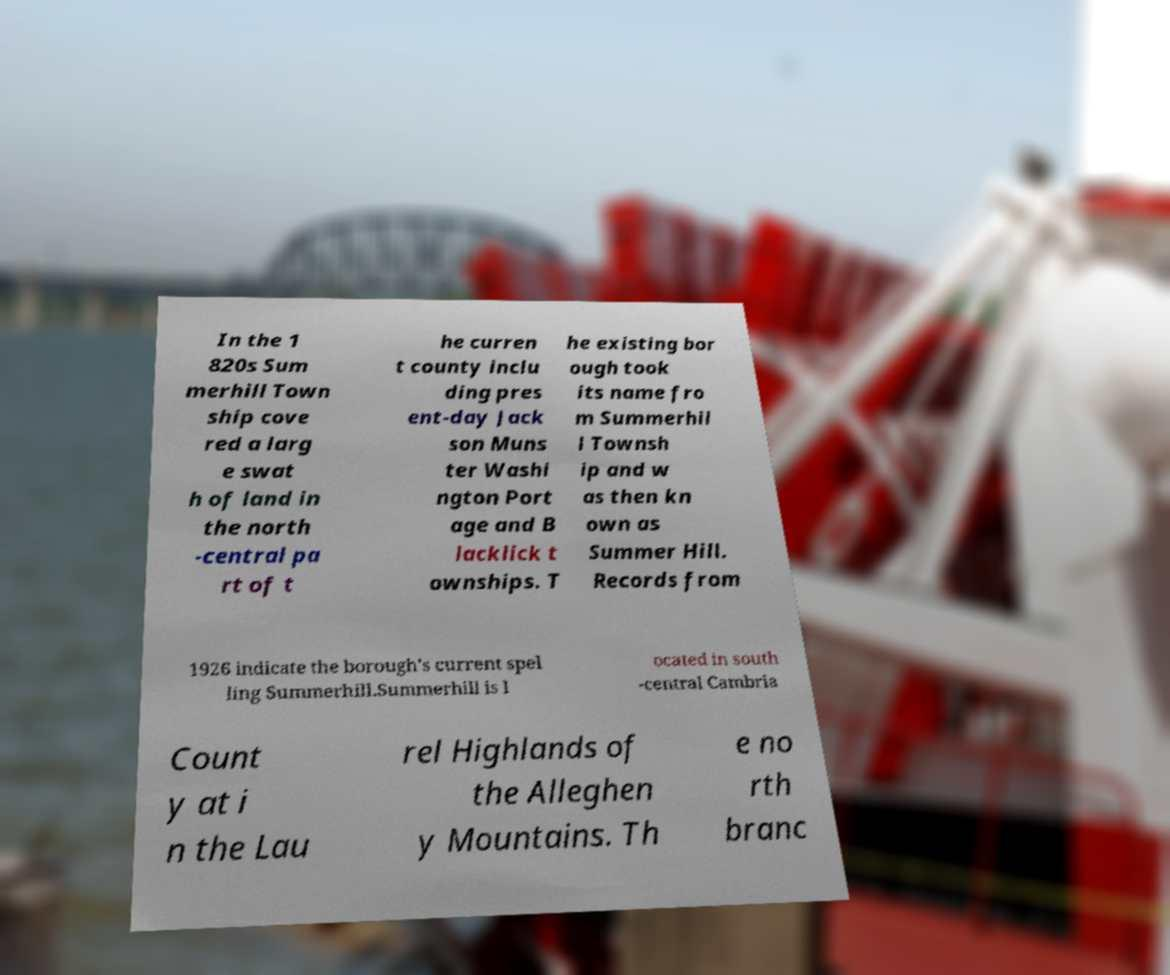Could you extract and type out the text from this image? In the 1 820s Sum merhill Town ship cove red a larg e swat h of land in the north -central pa rt of t he curren t county inclu ding pres ent-day Jack son Muns ter Washi ngton Port age and B lacklick t ownships. T he existing bor ough took its name fro m Summerhil l Townsh ip and w as then kn own as Summer Hill. Records from 1926 indicate the borough's current spel ling Summerhill.Summerhill is l ocated in south -central Cambria Count y at i n the Lau rel Highlands of the Alleghen y Mountains. Th e no rth branc 